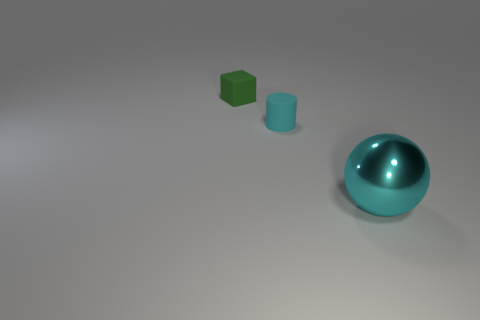Is there another tiny object made of the same material as the small cyan thing?
Offer a terse response. Yes. There is a cyan thing left of the cyan shiny ball; is there a cyan thing in front of it?
Offer a very short reply. Yes. Do the cyan thing to the right of the cyan cylinder and the small matte block have the same size?
Your response must be concise. No. What is the size of the sphere?
Your answer should be very brief. Large. Are there any spheres of the same color as the tiny cylinder?
Offer a terse response. Yes. What number of small objects are metal blocks or cyan cylinders?
Offer a terse response. 1. What number of small rubber cubes are to the right of the big object?
Provide a succinct answer. 0. There is a large object that is the same color as the matte cylinder; what is it made of?
Give a very brief answer. Metal. What number of cylinders are either small gray things or matte things?
Your response must be concise. 1. What is the size of the cylinder that is the same color as the sphere?
Offer a terse response. Small. 